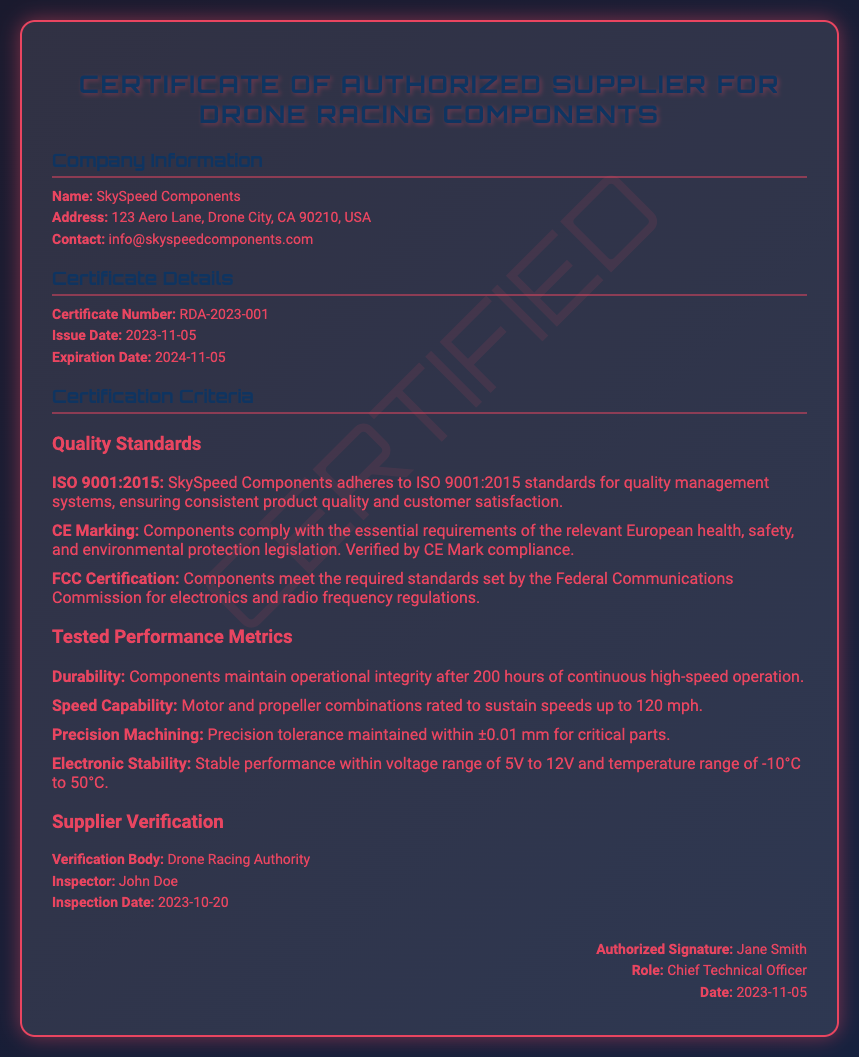What is the name of the company? The name of the company is provided in the company information section of the document.
Answer: SkySpeed Components What is the certificate number? The certificate number is stated in the certificate details section.
Answer: RDA-2023-001 When was the inspection conducted? The inspection date is mentioned in the supplier verification section of the document.
Answer: 2023-10-20 What is the expiration date of the certificate? The expiration date is specified in the certificate details section.
Answer: 2024-11-05 Which quality standard is associated with quality management systems? This information can be found under the quality standards section of the certification criteria.
Answer: ISO 9001:2015 What is the maximum speed capability of the components? The speed capability is stated under the tested performance metrics section.
Answer: 120 mph Who is the inspector for the verification? The inspector's name is listed in the supplier verification section of the document.
Answer: John Doe What is the role of the authorized signatory? The role is indicated in the signature section at the end of the document.
Answer: Chief Technical Officer What is the validity period of this certificate? The validity period can be inferred from the issue and expiration dates provided in the document.
Answer: One year 